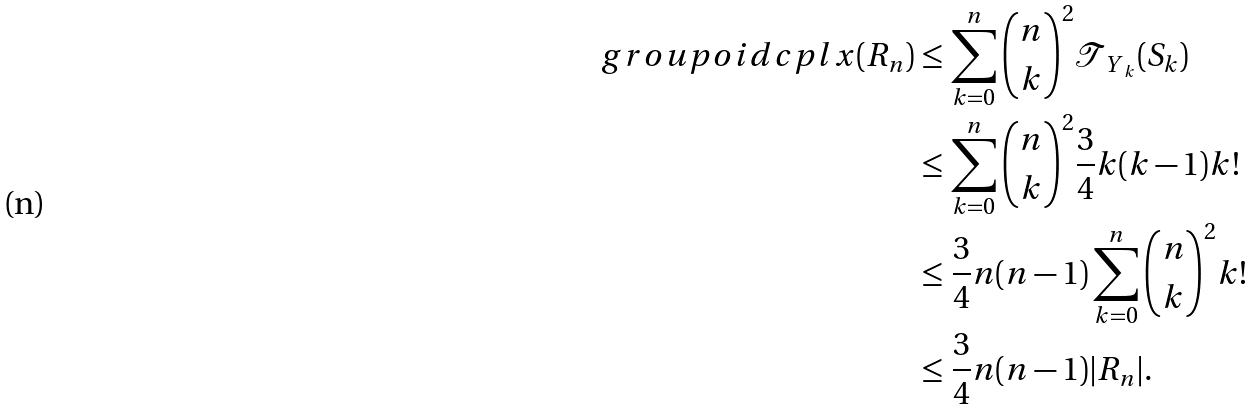<formula> <loc_0><loc_0><loc_500><loc_500>\ g r o u p o i d c p l x ( R _ { n } ) & \leq \sum _ { k = 0 } ^ { n } \binom { n } { k } ^ { 2 } { \mathcal { T } } _ { { \ Y } _ { k } } ( S _ { k } ) \\ & \leq \sum _ { k = 0 } ^ { n } \binom { n } { k } ^ { 2 } \frac { 3 } { 4 } k ( k - 1 ) k ! \\ & \leq \frac { 3 } { 4 } n ( n - 1 ) \sum _ { k = 0 } ^ { n } \binom { n } { k } ^ { 2 } k ! \\ & \leq \frac { 3 } { 4 } n ( n - 1 ) | R _ { n } | . \\</formula> 